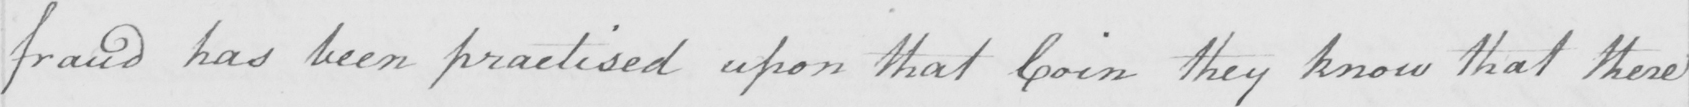Can you read and transcribe this handwriting? fraud has been practised upon that Coin they know that there 